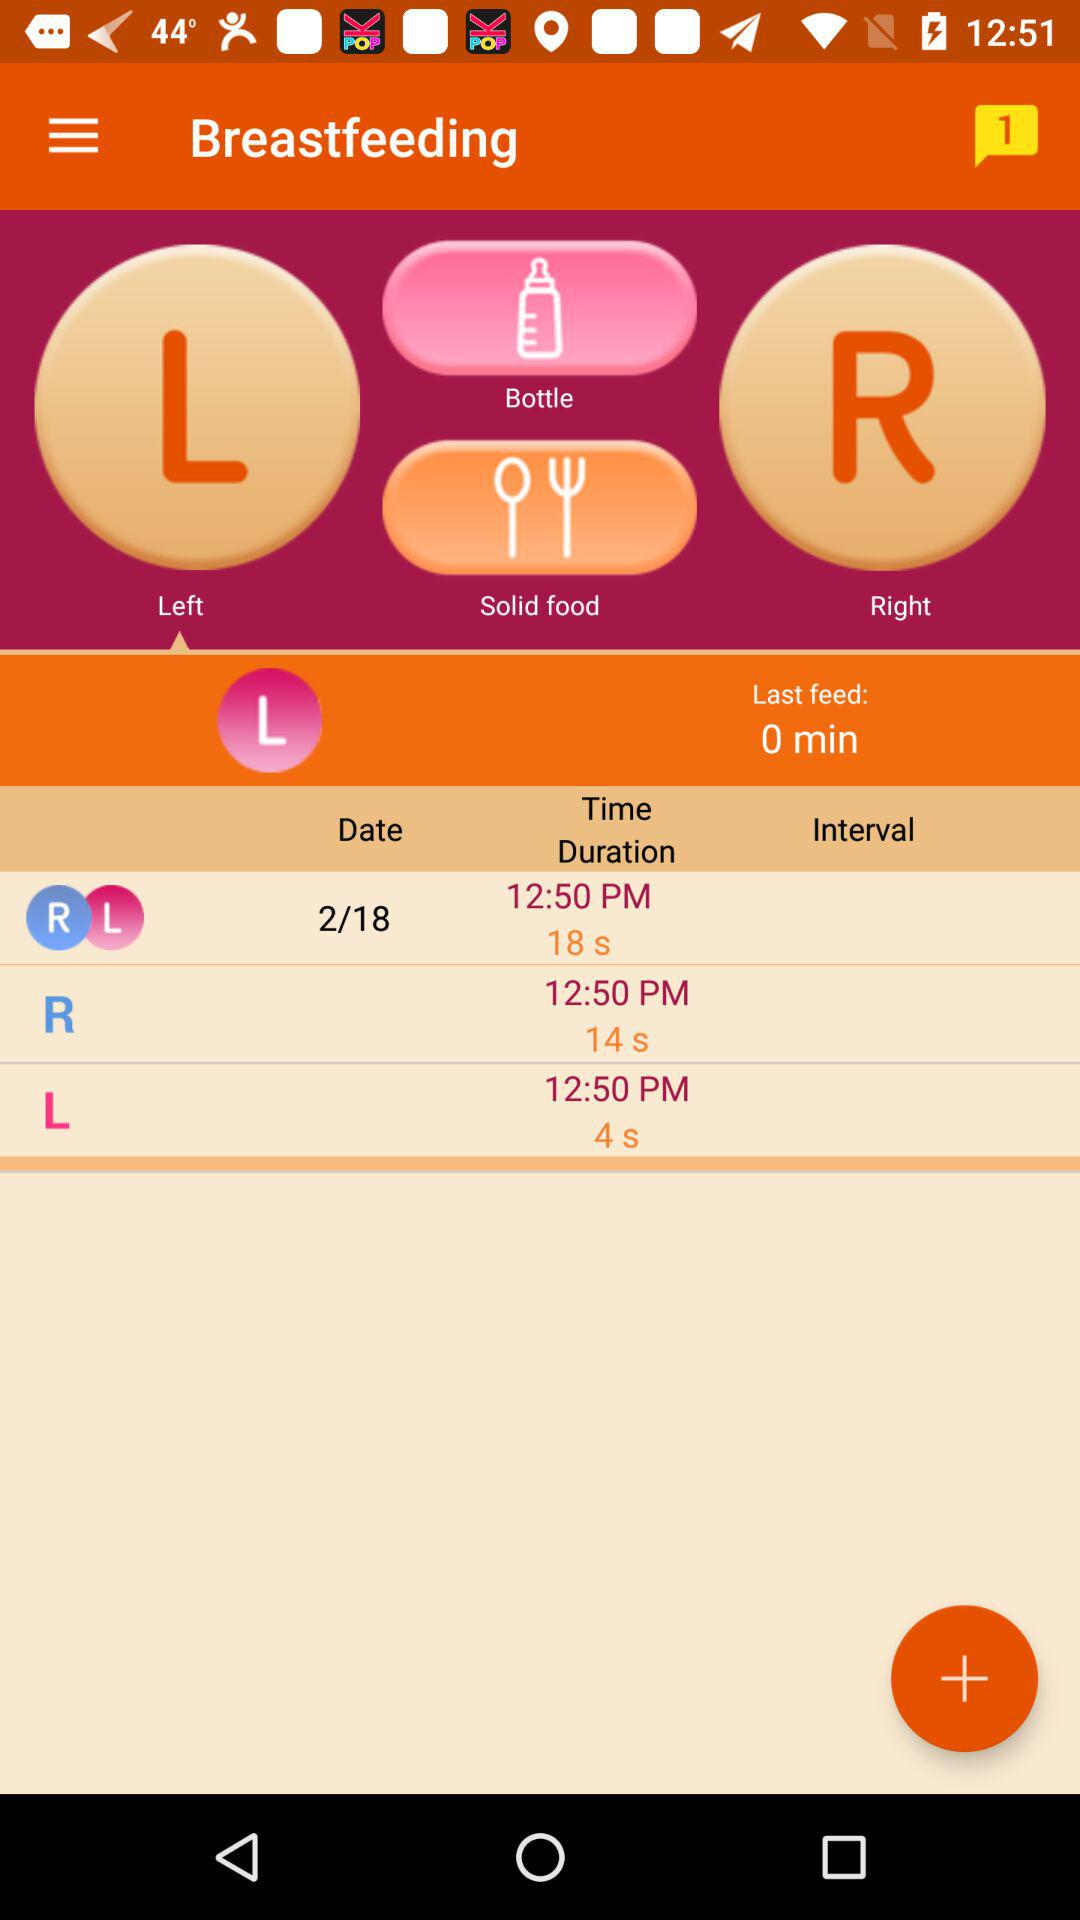What is the given date? The date is 2/18. 